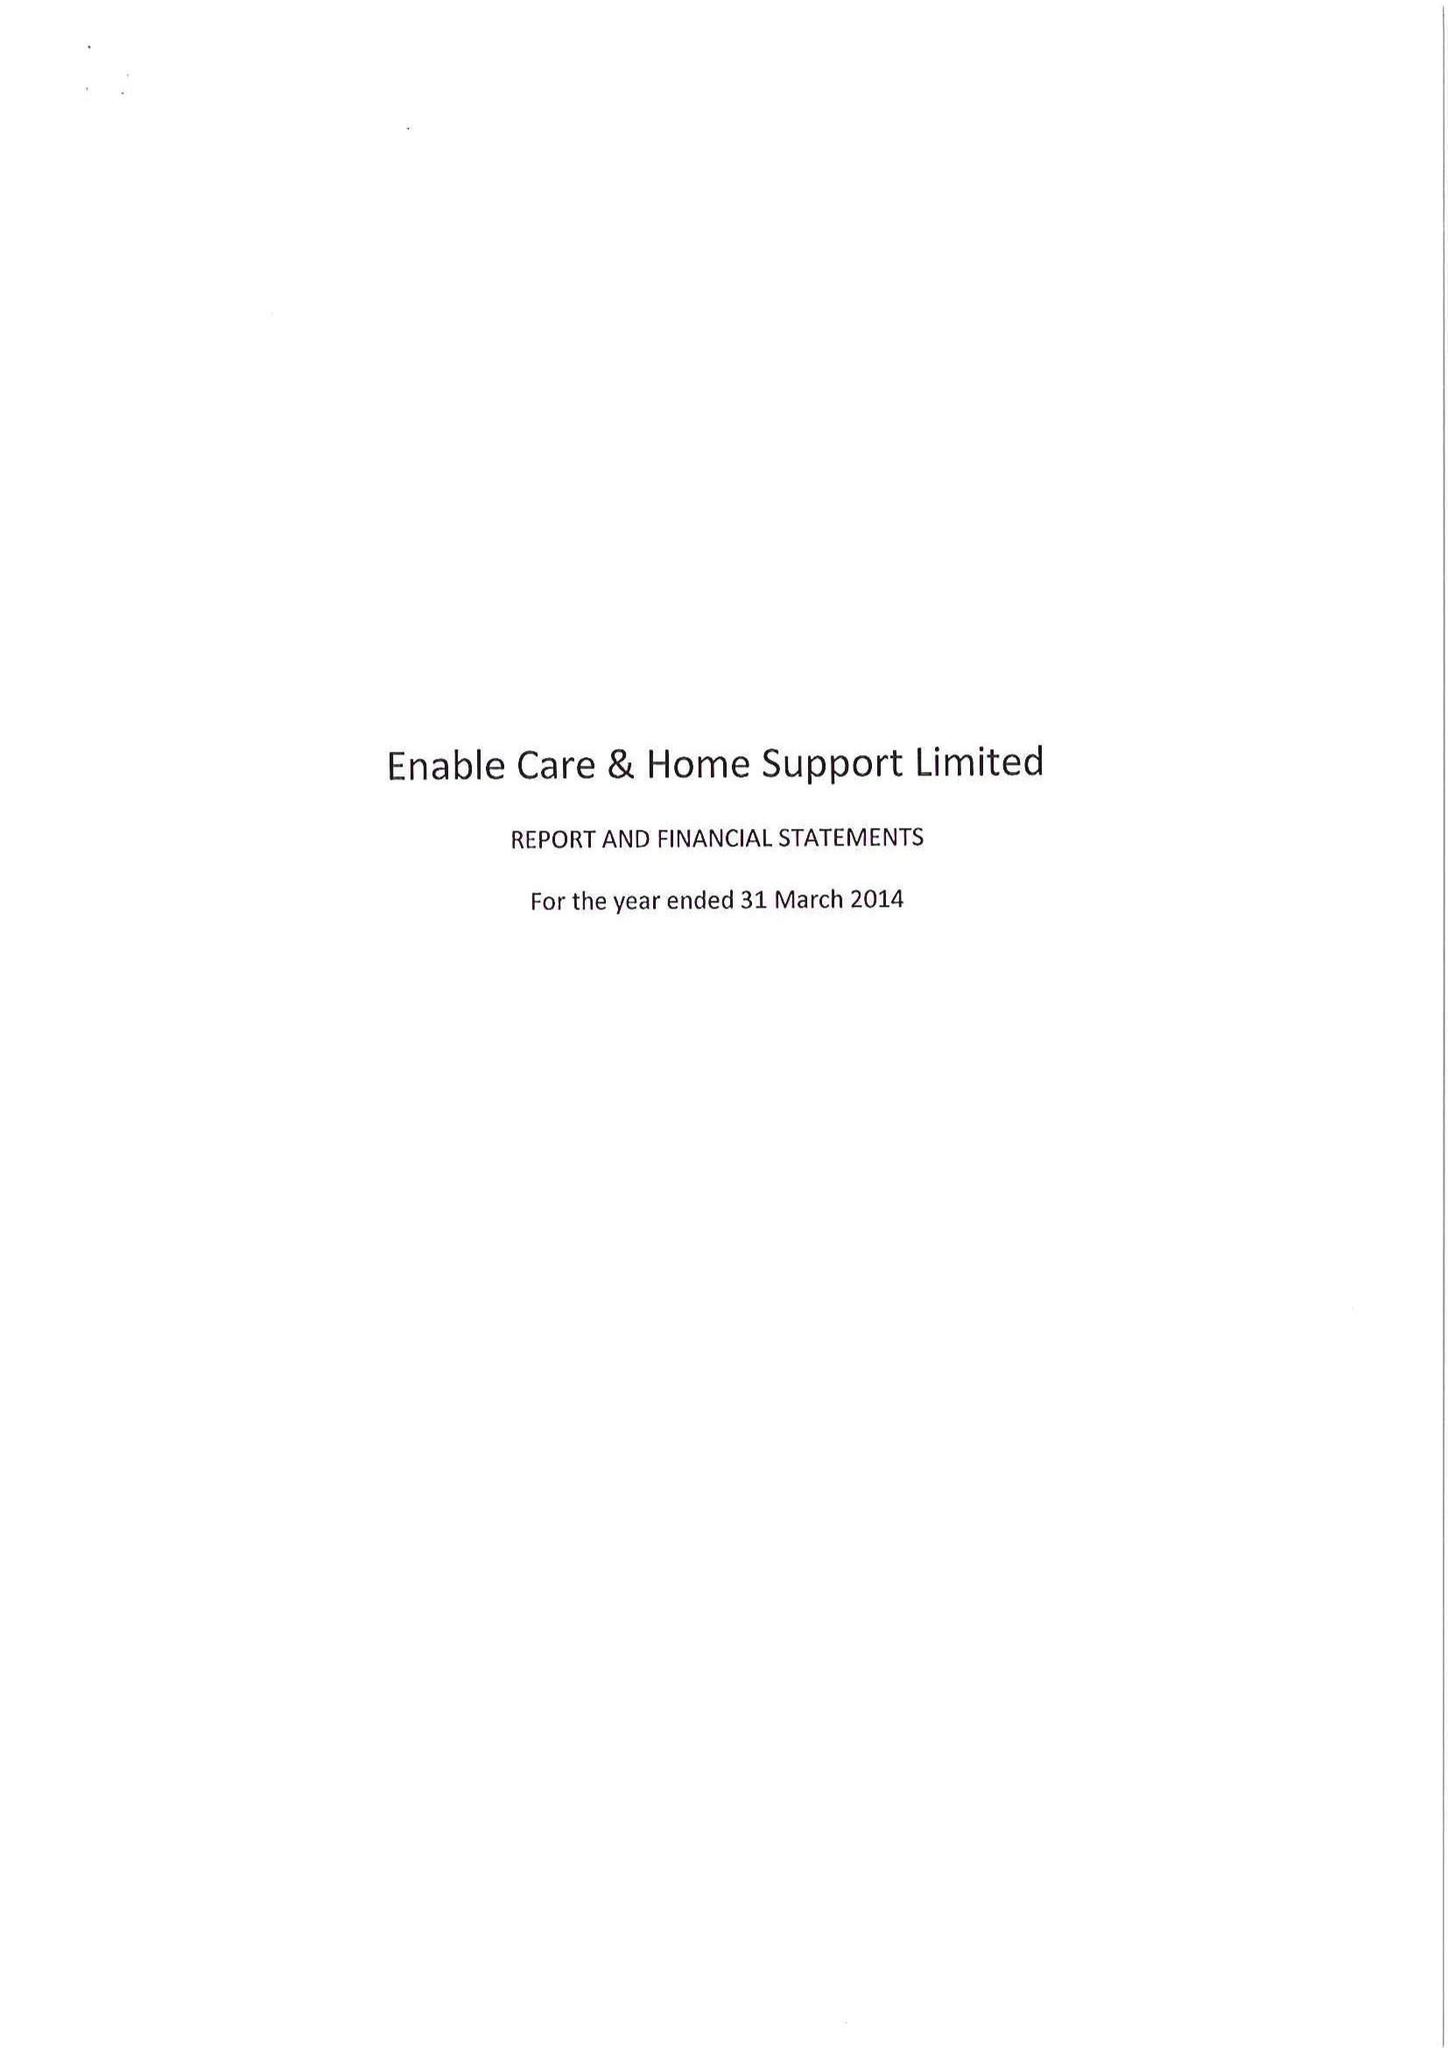What is the value for the charity_number?
Answer the question using a single word or phrase. 1001704 